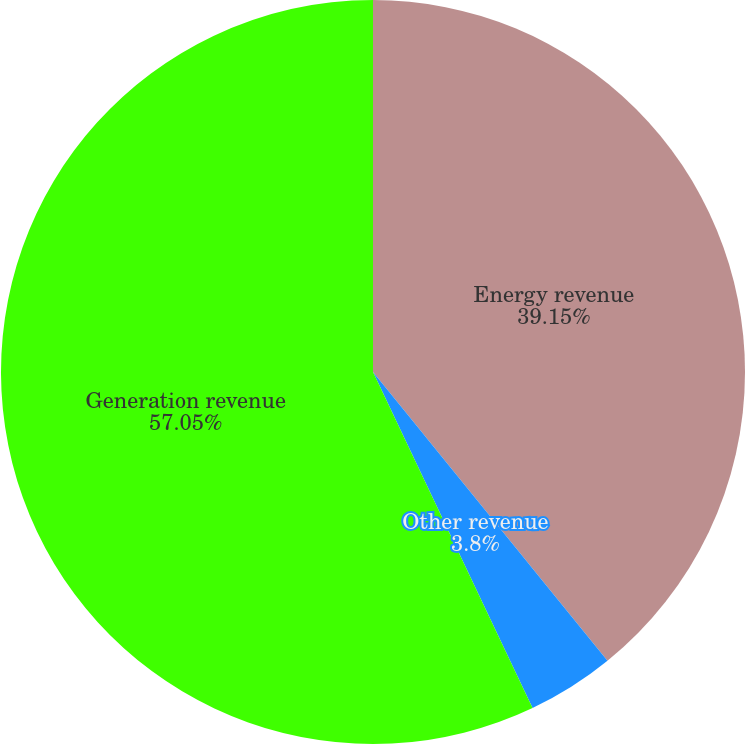Convert chart. <chart><loc_0><loc_0><loc_500><loc_500><pie_chart><fcel>Energy revenue<fcel>Other revenue<fcel>Generation revenue<nl><fcel>39.15%<fcel>3.8%<fcel>57.06%<nl></chart> 